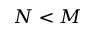<formula> <loc_0><loc_0><loc_500><loc_500>N < M</formula> 